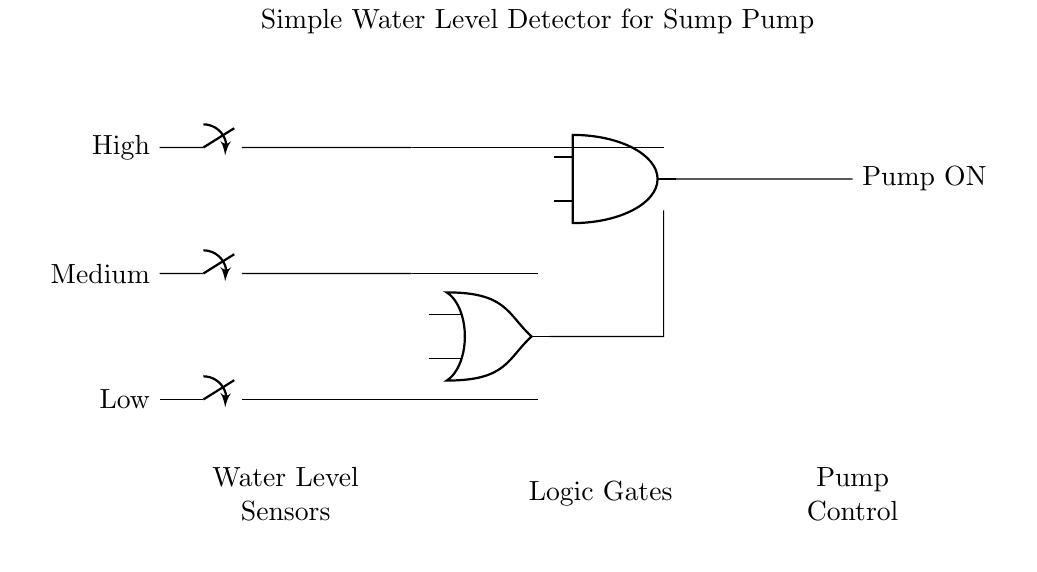What are the three water level indicators? The circuit indicates three water levels: Low, Medium, and High. Each level is monitored by a separate closing switch.
Answer: Low, Medium, High What type of logic gate is used to combine the Low and Medium sensors? The Low and Medium sensors' signals are combined using an OR gate, which outputs a high signal if either input sensor is activated.
Answer: OR gate How does the pump get activated? The pump is activated when the output of the AND gate goes high, which occurs only when the High sensor is activated and the output from the OR gate is also high.
Answer: Pump ON What is the role of the AND gate in this circuit? The AND gate ensures that the pump will only turn on when the water level is classified as High and either Low or Medium is also detected, preventing pump operation if the water is dangerously low.
Answer: Controls pump activation How many closing switches are used in total? There are three closing switches, one for each of the Low, Medium, and High water level sensors, in the circuit.
Answer: Three switches What does the output of the OR gate signify? The output of the OR gate signifies that either the Low or Medium water level has been detected, which helps indicate whether the water level is rising to a point that requires the pump to be considered for activation.
Answer: Indicates water level detection 